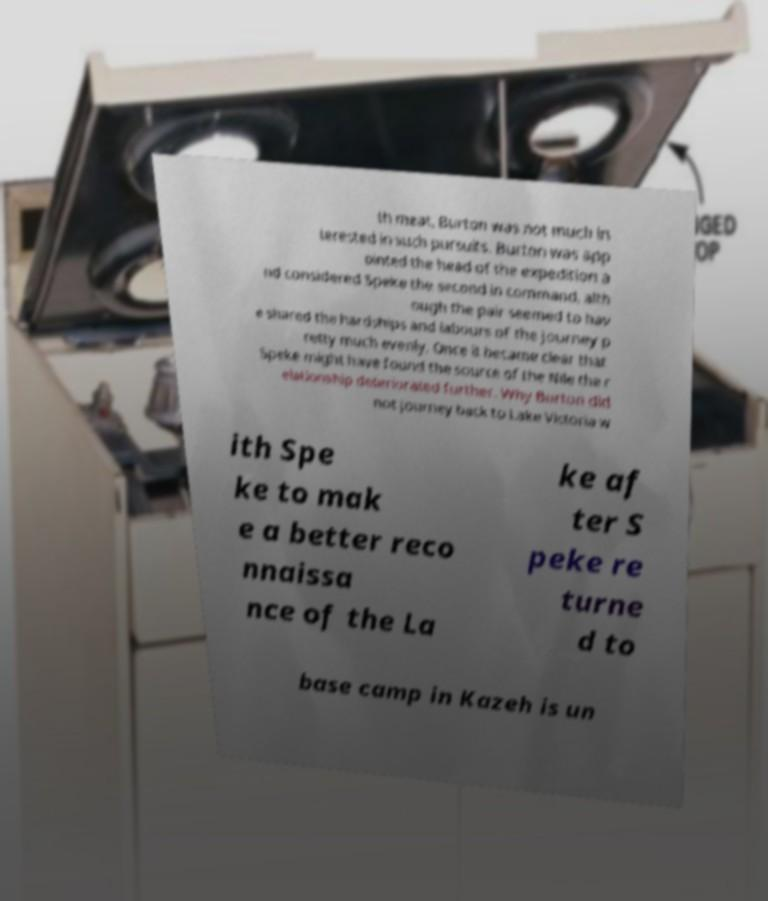For documentation purposes, I need the text within this image transcribed. Could you provide that? th meat, Burton was not much in terested in such pursuits. Burton was app ointed the head of the expedition a nd considered Speke the second in command, alth ough the pair seemed to hav e shared the hardships and labours of the journey p retty much evenly. Once it became clear that Speke might have found the source of the Nile the r elationship deteriorated further. Why Burton did not journey back to Lake Victoria w ith Spe ke to mak e a better reco nnaissa nce of the La ke af ter S peke re turne d to base camp in Kazeh is un 